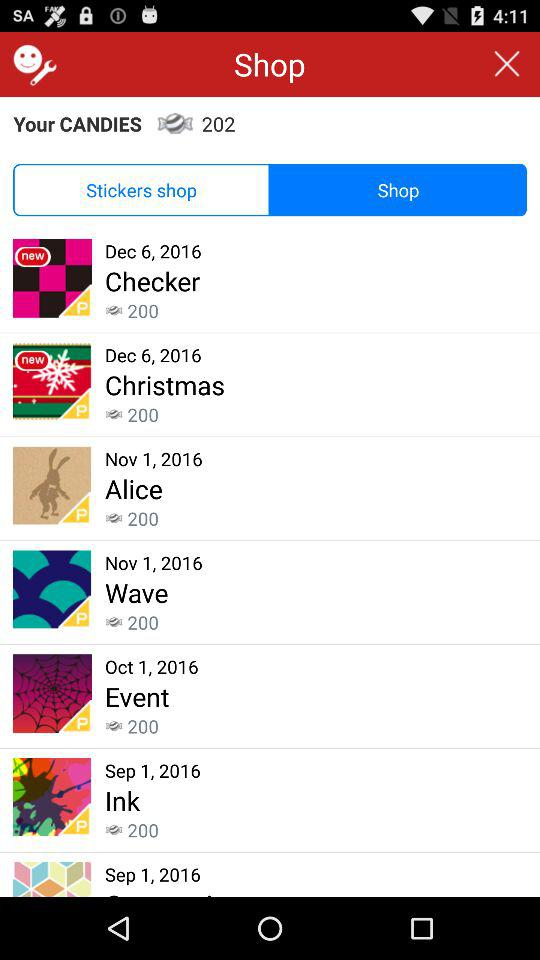How many candies are there for "Ink"? There are 200 candies. 